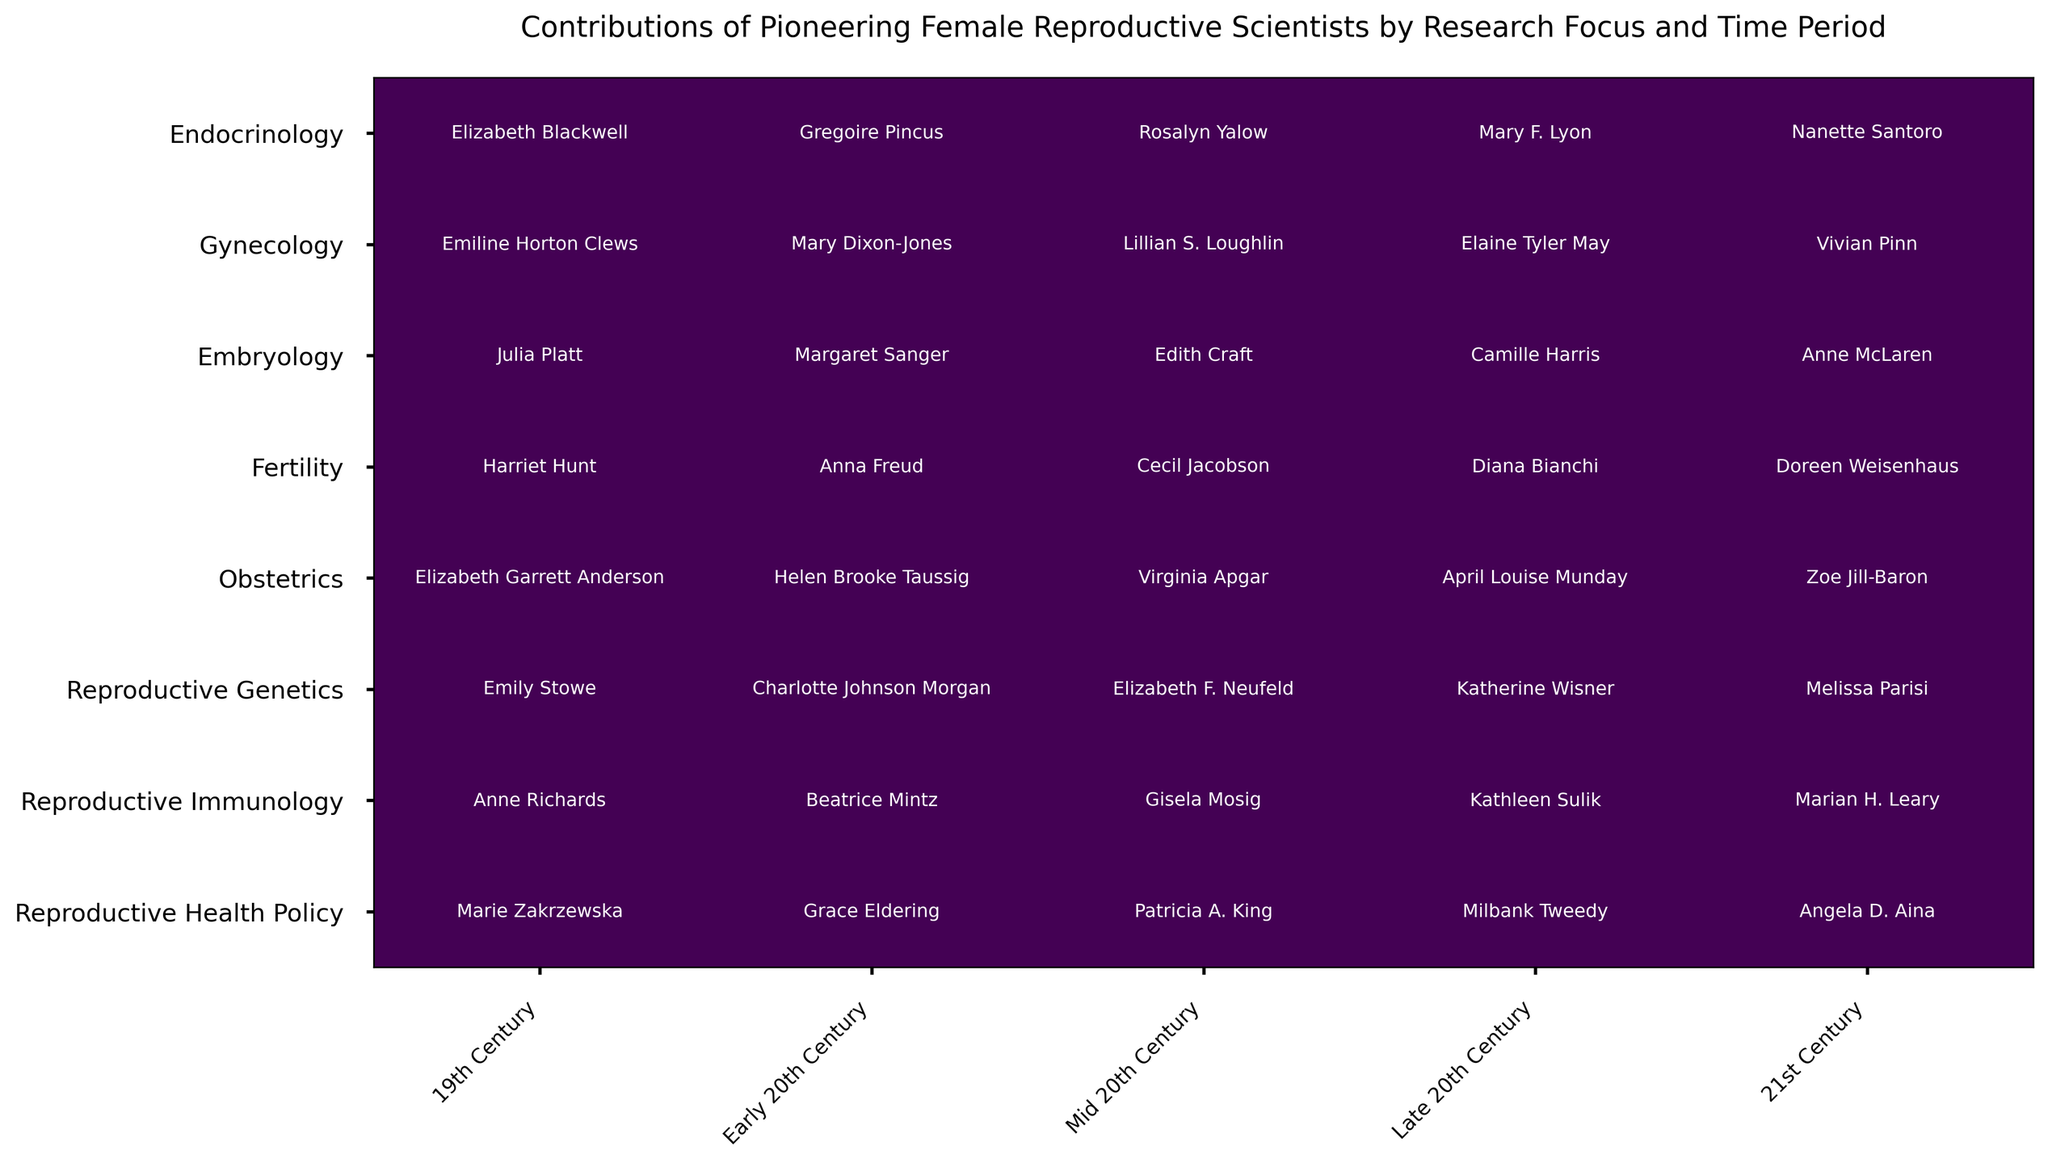Which research focus had contributions across all time periods? To determine this, we need to check each row to see if it has a contribution listed in every time period column. Both "Gynecology" and "Obstetrics" have contributions in the 19th Century, Early 20th Century, Mid 20th Century, Late 20th Century, and 21st Century.
Answer: Gynecology, Obstetrics Comparing Endocrinology and Fertility, which time period had the same scientist contributing in both fields? We need to look for names that appear in both the Endocrinology and Fertility rows for any time period column. No names repeat across these two research focuses in any given time period.
Answer: None Which research focus has the same scientist's name listed consecutively in two adjacent time periods? We need to examine each row to check if any scientist's name appears in two consecutive time periods without changing. No scientist's name appears consecutively in two adjacent time periods.
Answer: None Is there a research focus that had no contributions listed from the 19th Century? We should scan the 19th Century column to identify if any research focus row is blank. All listed research focuses feature contributions in the 19th Century.
Answer: No Who contributed to Gynecology in the Late 20th Century? We look at the cell where the Gynecology row intersects with the Late 20th Century column. The contributor listed is Elaine Tyler May.
Answer: Elaine Tyler May Which research focus has the most different contributor names across all time periods? Count the unique names in each row and compare. "Reproductive Health Policy" has contributors Marie Zakrzewska, Grace Eldering, Patricia A. King, Milbank Tweedy, and Angela D. Aina, each name unique.
Answer: Reproductive Health Policy For "Obstetrics," how many centuries did Elizabeth Garrett Anderson contribute? Check the "Obstetrics" row across the table and look for Elizabeth Garrett Anderson. She contributed in the 19th Century only.
Answer: 1 Century Which time period has the highest number of unique contributors across all research focuses? Count the contributors in each column, ensuring names are not repeated in counting. The 21st Century shows the highest diversity with names Nanette Santoro, Vivian Pinn, Anne McLaren, Doreen Weisenhaus, Zoe Jill-Baron, Melissa Parisi, Marian H. Leary, and Angela D. Aina.
Answer: 21st Century Who contributed to Reproductive Genetics in the Mid 20th Century? Look at the cell where the Reproductive Genetics row intersects with the Mid 20th Century column. The contributor is Elizabeth F. Neufeld.
Answer: Elizabeth F. Neufeld Comparing Endocrinology and Reproductive Health Policy, which one had more contributors listed in the 21st Century? Count the names listed in the 21st Century column for both. Endocrinology has Nanette Santoro, and Reproductive Health Policy has Angela D. Aina. Both fields have one contributor each.
Answer: Equal 